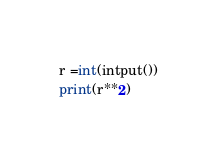<code> <loc_0><loc_0><loc_500><loc_500><_Python_>r =int(intput())
print(r**2)</code> 